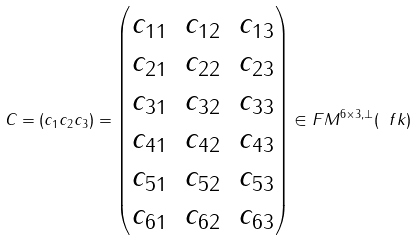Convert formula to latex. <formula><loc_0><loc_0><loc_500><loc_500>C = ( c _ { 1 } c _ { 2 } c _ { 3 } ) = \begin{pmatrix} c _ { 1 1 } & c _ { 1 2 } & c _ { 1 3 } \\ c _ { 2 1 } & c _ { 2 2 } & c _ { 2 3 } \\ c _ { 3 1 } & c _ { 3 2 } & c _ { 3 3 } \\ c _ { 4 1 } & c _ { 4 2 } & c _ { 4 3 } \\ c _ { 5 1 } & c _ { 5 2 } & c _ { 5 3 } \\ c _ { 6 1 } & c _ { 6 2 } & c _ { 6 3 } \end{pmatrix} \in F M ^ { 6 \times 3 , \perp } ( \ f k )</formula> 